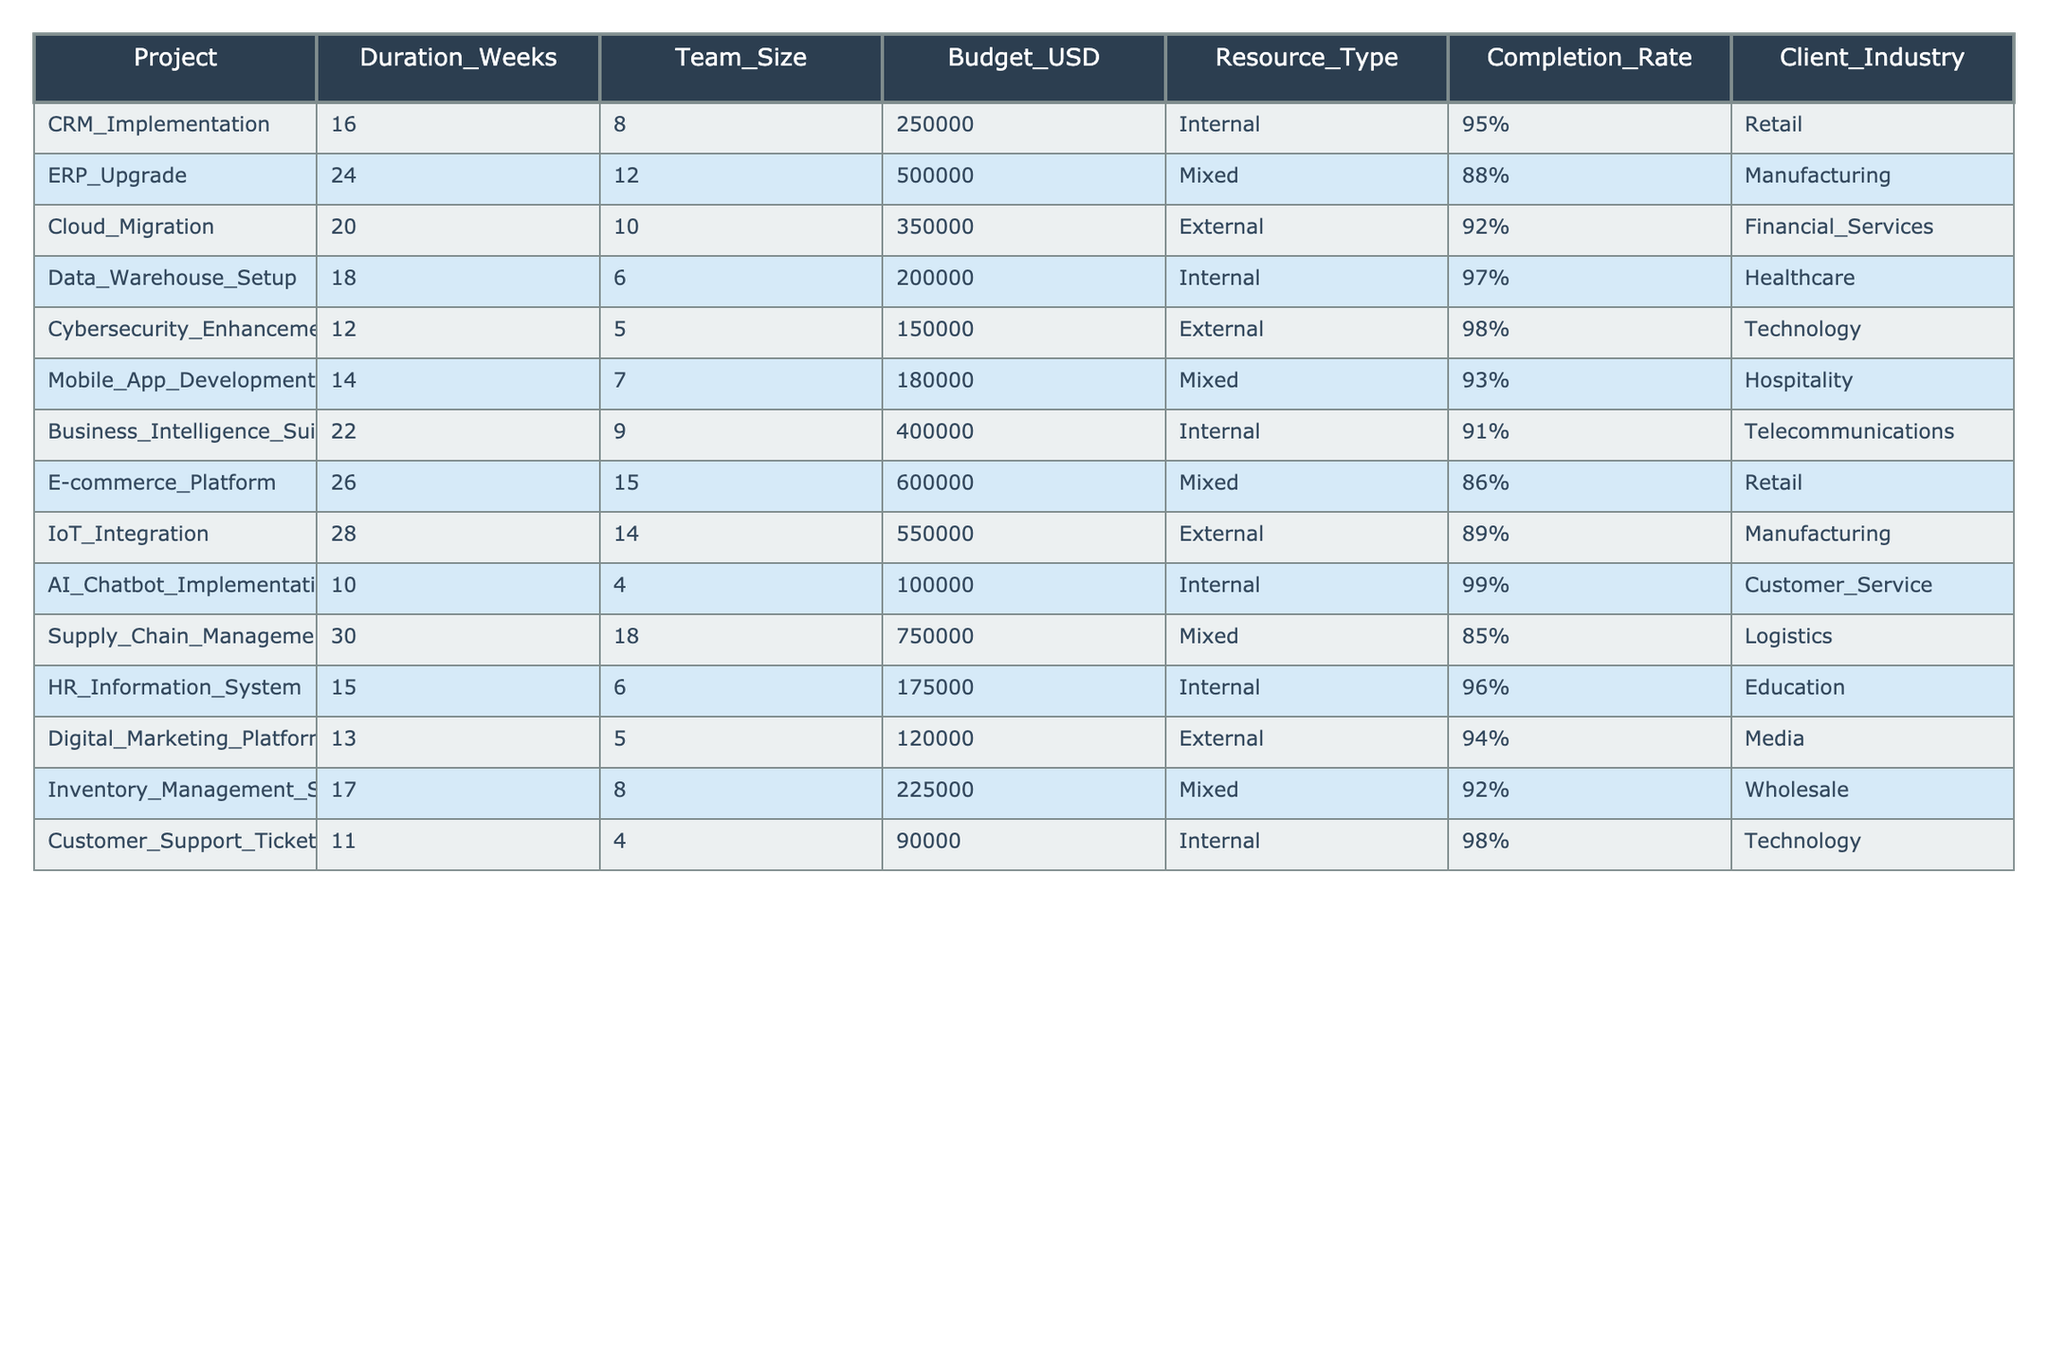What is the completion rate of the Cloud Migration project? The completion rate for the Cloud Migration project is listed as 92% in the table.
Answer: 92% Which project has the highest budget? The project with the highest budget is the Supply Chain Management System, which has a budget of 750,000 USD.
Answer: 750,000 USD How many weeks does the ERP Upgrade project take? The duration of the ERP Upgrade project is specified in the table as 24 weeks.
Answer: 24 weeks What is the average completion rate of Internal resource type projects? The completion rates for Internal projects are 95%, 97%, 91%, 99%, 96%, and 98%. Adding these rates gives 576%, and dividing by the number of Internal projects (6) yields an average of 96%.
Answer: 96% Is there a project in the technology industry that has a completion rate higher than 95%? The Cybersecurity Enhancement and Customer Support Ticketing System projects in the technology industry have completion rates of 98% and 98%, respectively, which are both higher than 95%. Thus, the statement is true.
Answer: Yes What is the difference in completion rates between the highest and lowest project completion rates? The highest completion rate is 99% from the AI Chatbot Implementation project, and the lowest is 85% from the Supply Chain Management System. The difference is 99% - 85% = 14%.
Answer: 14% If we consider only Mixed resource type projects, what is the total budget allocated? The Mixed resource type projects are ERP Upgrade (500,000 USD), Mobile App Development (180,000 USD), E-commerce Platform (600,000 USD), IoT Integration (550,000 USD), and Inventory Management Solution (225,000 USD). The total budget is 500,000 + 180,000 + 600,000 + 550,000 + 225,000 = 2,055,000 USD.
Answer: 2,055,000 USD Which project in the healthcare industry has the second highest completion rate? The Data Warehouse Setup project in the healthcare industry has a completion rate of 97%, and since it's the only project listed in healthcare, it is also the one with the second highest completion rate by default.
Answer: 97% How many projects took less than 15 weeks to complete? The projects that took less than 15 weeks are Cybersecurity Enhancement (12 weeks), AI Chatbot Implementation (10 weeks), and Customer Support Ticketing System (11 weeks), making a total of 3 projects.
Answer: 3 Which client industry has a project with a completion rate of 86%? The Retail industry has the E-commerce Platform project that has a completion rate of 86%.
Answer: Retail How many projects have a team size greater than 12? The projects with team size greater than 12 are the ERP Upgrade (12), E-commerce Platform (15), IoT Integration (14), and Supply Chain Management System (18), totaling 4 projects.
Answer: 4 